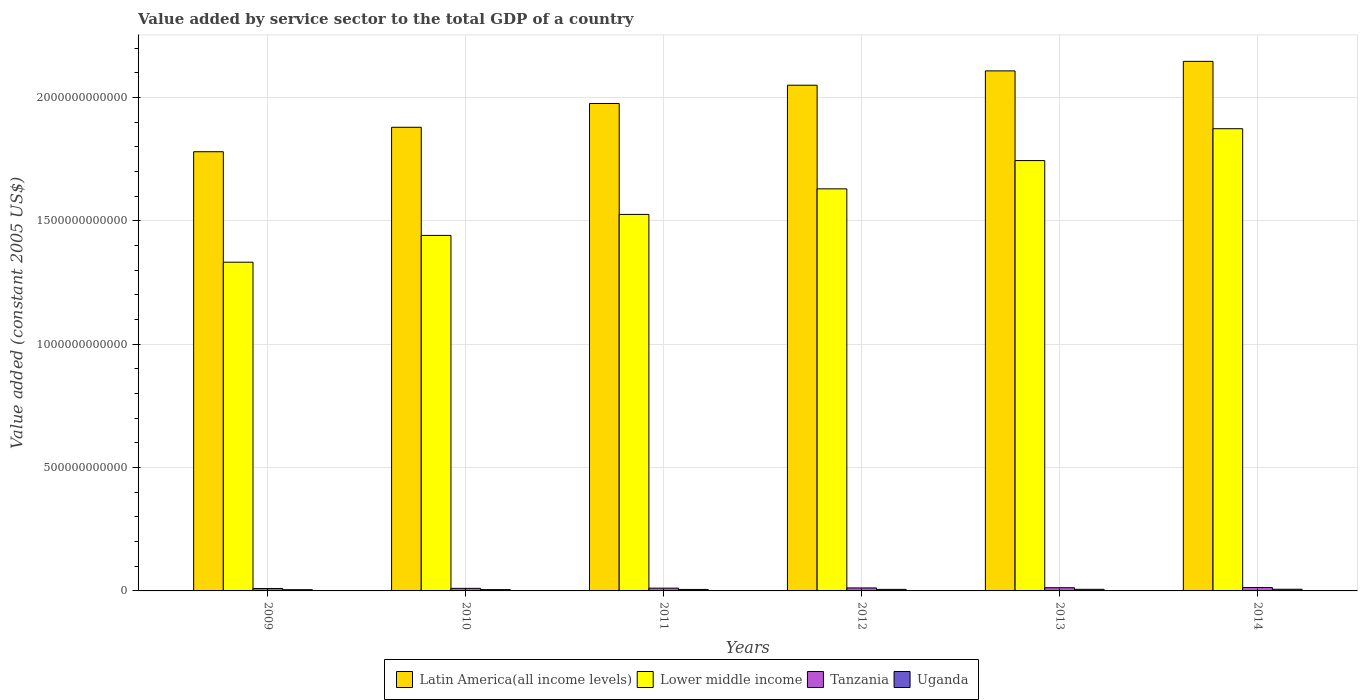How many groups of bars are there?
Keep it short and to the point. 6. Are the number of bars per tick equal to the number of legend labels?
Your answer should be very brief. Yes. How many bars are there on the 1st tick from the right?
Your answer should be very brief. 4. What is the label of the 1st group of bars from the left?
Make the answer very short. 2009. In how many cases, is the number of bars for a given year not equal to the number of legend labels?
Offer a very short reply. 0. What is the value added by service sector in Uganda in 2013?
Your answer should be very brief. 6.50e+09. Across all years, what is the maximum value added by service sector in Lower middle income?
Your answer should be compact. 1.87e+12. Across all years, what is the minimum value added by service sector in Latin America(all income levels)?
Ensure brevity in your answer.  1.78e+12. In which year was the value added by service sector in Lower middle income minimum?
Offer a terse response. 2009. What is the total value added by service sector in Latin America(all income levels) in the graph?
Give a very brief answer. 1.19e+13. What is the difference between the value added by service sector in Lower middle income in 2009 and that in 2013?
Your response must be concise. -4.12e+11. What is the difference between the value added by service sector in Uganda in 2010 and the value added by service sector in Lower middle income in 2012?
Provide a succinct answer. -1.62e+12. What is the average value added by service sector in Tanzania per year?
Offer a very short reply. 1.17e+1. In the year 2013, what is the difference between the value added by service sector in Lower middle income and value added by service sector in Tanzania?
Offer a very short reply. 1.73e+12. In how many years, is the value added by service sector in Lower middle income greater than 100000000000 US$?
Keep it short and to the point. 6. What is the ratio of the value added by service sector in Latin America(all income levels) in 2010 to that in 2014?
Give a very brief answer. 0.88. Is the difference between the value added by service sector in Lower middle income in 2010 and 2014 greater than the difference between the value added by service sector in Tanzania in 2010 and 2014?
Ensure brevity in your answer.  No. What is the difference between the highest and the second highest value added by service sector in Latin America(all income levels)?
Your answer should be very brief. 3.87e+1. What is the difference between the highest and the lowest value added by service sector in Uganda?
Make the answer very short. 1.78e+09. Is the sum of the value added by service sector in Latin America(all income levels) in 2012 and 2013 greater than the maximum value added by service sector in Tanzania across all years?
Ensure brevity in your answer.  Yes. What does the 4th bar from the left in 2014 represents?
Give a very brief answer. Uganda. What does the 4th bar from the right in 2014 represents?
Offer a very short reply. Latin America(all income levels). Is it the case that in every year, the sum of the value added by service sector in Tanzania and value added by service sector in Latin America(all income levels) is greater than the value added by service sector in Lower middle income?
Offer a terse response. Yes. Are all the bars in the graph horizontal?
Your response must be concise. No. How many years are there in the graph?
Provide a short and direct response. 6. What is the difference between two consecutive major ticks on the Y-axis?
Make the answer very short. 5.00e+11. Are the values on the major ticks of Y-axis written in scientific E-notation?
Provide a succinct answer. No. Does the graph contain any zero values?
Make the answer very short. No. How many legend labels are there?
Keep it short and to the point. 4. How are the legend labels stacked?
Offer a terse response. Horizontal. What is the title of the graph?
Your answer should be very brief. Value added by service sector to the total GDP of a country. Does "Thailand" appear as one of the legend labels in the graph?
Keep it short and to the point. No. What is the label or title of the X-axis?
Ensure brevity in your answer.  Years. What is the label or title of the Y-axis?
Your answer should be compact. Value added (constant 2005 US$). What is the Value added (constant 2005 US$) in Latin America(all income levels) in 2009?
Offer a terse response. 1.78e+12. What is the Value added (constant 2005 US$) in Lower middle income in 2009?
Ensure brevity in your answer.  1.33e+12. What is the Value added (constant 2005 US$) in Tanzania in 2009?
Your response must be concise. 9.69e+09. What is the Value added (constant 2005 US$) of Uganda in 2009?
Offer a terse response. 5.00e+09. What is the Value added (constant 2005 US$) in Latin America(all income levels) in 2010?
Your response must be concise. 1.88e+12. What is the Value added (constant 2005 US$) in Lower middle income in 2010?
Your response must be concise. 1.44e+12. What is the Value added (constant 2005 US$) of Tanzania in 2010?
Offer a very short reply. 1.04e+1. What is the Value added (constant 2005 US$) of Uganda in 2010?
Keep it short and to the point. 5.30e+09. What is the Value added (constant 2005 US$) in Latin America(all income levels) in 2011?
Provide a succinct answer. 1.98e+12. What is the Value added (constant 2005 US$) of Lower middle income in 2011?
Ensure brevity in your answer.  1.53e+12. What is the Value added (constant 2005 US$) in Tanzania in 2011?
Give a very brief answer. 1.13e+1. What is the Value added (constant 2005 US$) in Uganda in 2011?
Keep it short and to the point. 5.96e+09. What is the Value added (constant 2005 US$) in Latin America(all income levels) in 2012?
Offer a terse response. 2.05e+12. What is the Value added (constant 2005 US$) in Lower middle income in 2012?
Your answer should be very brief. 1.63e+12. What is the Value added (constant 2005 US$) in Tanzania in 2012?
Your response must be concise. 1.21e+1. What is the Value added (constant 2005 US$) in Uganda in 2012?
Provide a short and direct response. 6.25e+09. What is the Value added (constant 2005 US$) in Latin America(all income levels) in 2013?
Give a very brief answer. 2.11e+12. What is the Value added (constant 2005 US$) of Lower middle income in 2013?
Make the answer very short. 1.74e+12. What is the Value added (constant 2005 US$) of Tanzania in 2013?
Keep it short and to the point. 1.30e+1. What is the Value added (constant 2005 US$) in Uganda in 2013?
Your answer should be compact. 6.50e+09. What is the Value added (constant 2005 US$) in Latin America(all income levels) in 2014?
Offer a terse response. 2.15e+12. What is the Value added (constant 2005 US$) in Lower middle income in 2014?
Your answer should be compact. 1.87e+12. What is the Value added (constant 2005 US$) in Tanzania in 2014?
Provide a short and direct response. 1.39e+1. What is the Value added (constant 2005 US$) in Uganda in 2014?
Your response must be concise. 6.78e+09. Across all years, what is the maximum Value added (constant 2005 US$) in Latin America(all income levels)?
Your answer should be very brief. 2.15e+12. Across all years, what is the maximum Value added (constant 2005 US$) of Lower middle income?
Make the answer very short. 1.87e+12. Across all years, what is the maximum Value added (constant 2005 US$) in Tanzania?
Provide a short and direct response. 1.39e+1. Across all years, what is the maximum Value added (constant 2005 US$) in Uganda?
Your response must be concise. 6.78e+09. Across all years, what is the minimum Value added (constant 2005 US$) of Latin America(all income levels)?
Your response must be concise. 1.78e+12. Across all years, what is the minimum Value added (constant 2005 US$) in Lower middle income?
Ensure brevity in your answer.  1.33e+12. Across all years, what is the minimum Value added (constant 2005 US$) in Tanzania?
Offer a very short reply. 9.69e+09. Across all years, what is the minimum Value added (constant 2005 US$) in Uganda?
Provide a succinct answer. 5.00e+09. What is the total Value added (constant 2005 US$) of Latin America(all income levels) in the graph?
Offer a very short reply. 1.19e+13. What is the total Value added (constant 2005 US$) in Lower middle income in the graph?
Keep it short and to the point. 9.55e+12. What is the total Value added (constant 2005 US$) of Tanzania in the graph?
Your answer should be very brief. 7.04e+1. What is the total Value added (constant 2005 US$) of Uganda in the graph?
Ensure brevity in your answer.  3.58e+1. What is the difference between the Value added (constant 2005 US$) in Latin America(all income levels) in 2009 and that in 2010?
Offer a terse response. -9.91e+1. What is the difference between the Value added (constant 2005 US$) of Lower middle income in 2009 and that in 2010?
Your response must be concise. -1.09e+11. What is the difference between the Value added (constant 2005 US$) of Tanzania in 2009 and that in 2010?
Give a very brief answer. -7.53e+08. What is the difference between the Value added (constant 2005 US$) in Uganda in 2009 and that in 2010?
Ensure brevity in your answer.  -2.97e+08. What is the difference between the Value added (constant 2005 US$) in Latin America(all income levels) in 2009 and that in 2011?
Your answer should be compact. -1.96e+11. What is the difference between the Value added (constant 2005 US$) of Lower middle income in 2009 and that in 2011?
Your answer should be compact. -1.94e+11. What is the difference between the Value added (constant 2005 US$) of Tanzania in 2009 and that in 2011?
Keep it short and to the point. -1.58e+09. What is the difference between the Value added (constant 2005 US$) in Uganda in 2009 and that in 2011?
Offer a terse response. -9.52e+08. What is the difference between the Value added (constant 2005 US$) in Latin America(all income levels) in 2009 and that in 2012?
Your answer should be compact. -2.70e+11. What is the difference between the Value added (constant 2005 US$) of Lower middle income in 2009 and that in 2012?
Give a very brief answer. -2.97e+11. What is the difference between the Value added (constant 2005 US$) of Tanzania in 2009 and that in 2012?
Give a very brief answer. -2.42e+09. What is the difference between the Value added (constant 2005 US$) in Uganda in 2009 and that in 2012?
Make the answer very short. -1.25e+09. What is the difference between the Value added (constant 2005 US$) in Latin America(all income levels) in 2009 and that in 2013?
Make the answer very short. -3.28e+11. What is the difference between the Value added (constant 2005 US$) in Lower middle income in 2009 and that in 2013?
Give a very brief answer. -4.12e+11. What is the difference between the Value added (constant 2005 US$) in Tanzania in 2009 and that in 2013?
Make the answer very short. -3.31e+09. What is the difference between the Value added (constant 2005 US$) of Uganda in 2009 and that in 2013?
Give a very brief answer. -1.50e+09. What is the difference between the Value added (constant 2005 US$) of Latin America(all income levels) in 2009 and that in 2014?
Give a very brief answer. -3.66e+11. What is the difference between the Value added (constant 2005 US$) of Lower middle income in 2009 and that in 2014?
Offer a terse response. -5.41e+11. What is the difference between the Value added (constant 2005 US$) in Tanzania in 2009 and that in 2014?
Provide a short and direct response. -4.24e+09. What is the difference between the Value added (constant 2005 US$) of Uganda in 2009 and that in 2014?
Provide a short and direct response. -1.78e+09. What is the difference between the Value added (constant 2005 US$) of Latin America(all income levels) in 2010 and that in 2011?
Your response must be concise. -9.64e+1. What is the difference between the Value added (constant 2005 US$) of Lower middle income in 2010 and that in 2011?
Offer a very short reply. -8.51e+1. What is the difference between the Value added (constant 2005 US$) in Tanzania in 2010 and that in 2011?
Give a very brief answer. -8.30e+08. What is the difference between the Value added (constant 2005 US$) of Uganda in 2010 and that in 2011?
Your answer should be compact. -6.55e+08. What is the difference between the Value added (constant 2005 US$) in Latin America(all income levels) in 2010 and that in 2012?
Keep it short and to the point. -1.70e+11. What is the difference between the Value added (constant 2005 US$) of Lower middle income in 2010 and that in 2012?
Provide a short and direct response. -1.89e+11. What is the difference between the Value added (constant 2005 US$) in Tanzania in 2010 and that in 2012?
Provide a succinct answer. -1.67e+09. What is the difference between the Value added (constant 2005 US$) of Uganda in 2010 and that in 2012?
Offer a terse response. -9.49e+08. What is the difference between the Value added (constant 2005 US$) of Latin America(all income levels) in 2010 and that in 2013?
Keep it short and to the point. -2.29e+11. What is the difference between the Value added (constant 2005 US$) in Lower middle income in 2010 and that in 2013?
Your answer should be compact. -3.03e+11. What is the difference between the Value added (constant 2005 US$) in Tanzania in 2010 and that in 2013?
Give a very brief answer. -2.56e+09. What is the difference between the Value added (constant 2005 US$) of Uganda in 2010 and that in 2013?
Your answer should be compact. -1.20e+09. What is the difference between the Value added (constant 2005 US$) in Latin America(all income levels) in 2010 and that in 2014?
Your answer should be compact. -2.67e+11. What is the difference between the Value added (constant 2005 US$) of Lower middle income in 2010 and that in 2014?
Ensure brevity in your answer.  -4.33e+11. What is the difference between the Value added (constant 2005 US$) in Tanzania in 2010 and that in 2014?
Offer a terse response. -3.48e+09. What is the difference between the Value added (constant 2005 US$) of Uganda in 2010 and that in 2014?
Ensure brevity in your answer.  -1.48e+09. What is the difference between the Value added (constant 2005 US$) of Latin America(all income levels) in 2011 and that in 2012?
Your response must be concise. -7.41e+1. What is the difference between the Value added (constant 2005 US$) in Lower middle income in 2011 and that in 2012?
Ensure brevity in your answer.  -1.04e+11. What is the difference between the Value added (constant 2005 US$) in Tanzania in 2011 and that in 2012?
Give a very brief answer. -8.38e+08. What is the difference between the Value added (constant 2005 US$) of Uganda in 2011 and that in 2012?
Make the answer very short. -2.94e+08. What is the difference between the Value added (constant 2005 US$) in Latin America(all income levels) in 2011 and that in 2013?
Your answer should be very brief. -1.32e+11. What is the difference between the Value added (constant 2005 US$) of Lower middle income in 2011 and that in 2013?
Ensure brevity in your answer.  -2.18e+11. What is the difference between the Value added (constant 2005 US$) in Tanzania in 2011 and that in 2013?
Ensure brevity in your answer.  -1.73e+09. What is the difference between the Value added (constant 2005 US$) of Uganda in 2011 and that in 2013?
Give a very brief answer. -5.47e+08. What is the difference between the Value added (constant 2005 US$) of Latin America(all income levels) in 2011 and that in 2014?
Give a very brief answer. -1.71e+11. What is the difference between the Value added (constant 2005 US$) in Lower middle income in 2011 and that in 2014?
Your answer should be compact. -3.47e+11. What is the difference between the Value added (constant 2005 US$) of Tanzania in 2011 and that in 2014?
Your response must be concise. -2.65e+09. What is the difference between the Value added (constant 2005 US$) of Uganda in 2011 and that in 2014?
Ensure brevity in your answer.  -8.27e+08. What is the difference between the Value added (constant 2005 US$) of Latin America(all income levels) in 2012 and that in 2013?
Keep it short and to the point. -5.81e+1. What is the difference between the Value added (constant 2005 US$) in Lower middle income in 2012 and that in 2013?
Ensure brevity in your answer.  -1.15e+11. What is the difference between the Value added (constant 2005 US$) in Tanzania in 2012 and that in 2013?
Provide a succinct answer. -8.90e+08. What is the difference between the Value added (constant 2005 US$) in Uganda in 2012 and that in 2013?
Offer a terse response. -2.53e+08. What is the difference between the Value added (constant 2005 US$) in Latin America(all income levels) in 2012 and that in 2014?
Provide a succinct answer. -9.67e+1. What is the difference between the Value added (constant 2005 US$) in Lower middle income in 2012 and that in 2014?
Provide a short and direct response. -2.44e+11. What is the difference between the Value added (constant 2005 US$) in Tanzania in 2012 and that in 2014?
Keep it short and to the point. -1.82e+09. What is the difference between the Value added (constant 2005 US$) of Uganda in 2012 and that in 2014?
Provide a short and direct response. -5.33e+08. What is the difference between the Value added (constant 2005 US$) of Latin America(all income levels) in 2013 and that in 2014?
Your response must be concise. -3.87e+1. What is the difference between the Value added (constant 2005 US$) of Lower middle income in 2013 and that in 2014?
Ensure brevity in your answer.  -1.29e+11. What is the difference between the Value added (constant 2005 US$) in Tanzania in 2013 and that in 2014?
Give a very brief answer. -9.26e+08. What is the difference between the Value added (constant 2005 US$) of Uganda in 2013 and that in 2014?
Your answer should be compact. -2.80e+08. What is the difference between the Value added (constant 2005 US$) of Latin America(all income levels) in 2009 and the Value added (constant 2005 US$) of Lower middle income in 2010?
Keep it short and to the point. 3.39e+11. What is the difference between the Value added (constant 2005 US$) of Latin America(all income levels) in 2009 and the Value added (constant 2005 US$) of Tanzania in 2010?
Provide a succinct answer. 1.77e+12. What is the difference between the Value added (constant 2005 US$) in Latin America(all income levels) in 2009 and the Value added (constant 2005 US$) in Uganda in 2010?
Provide a short and direct response. 1.78e+12. What is the difference between the Value added (constant 2005 US$) of Lower middle income in 2009 and the Value added (constant 2005 US$) of Tanzania in 2010?
Provide a short and direct response. 1.32e+12. What is the difference between the Value added (constant 2005 US$) of Lower middle income in 2009 and the Value added (constant 2005 US$) of Uganda in 2010?
Give a very brief answer. 1.33e+12. What is the difference between the Value added (constant 2005 US$) in Tanzania in 2009 and the Value added (constant 2005 US$) in Uganda in 2010?
Make the answer very short. 4.39e+09. What is the difference between the Value added (constant 2005 US$) of Latin America(all income levels) in 2009 and the Value added (constant 2005 US$) of Lower middle income in 2011?
Your answer should be very brief. 2.54e+11. What is the difference between the Value added (constant 2005 US$) in Latin America(all income levels) in 2009 and the Value added (constant 2005 US$) in Tanzania in 2011?
Ensure brevity in your answer.  1.77e+12. What is the difference between the Value added (constant 2005 US$) in Latin America(all income levels) in 2009 and the Value added (constant 2005 US$) in Uganda in 2011?
Your answer should be very brief. 1.77e+12. What is the difference between the Value added (constant 2005 US$) in Lower middle income in 2009 and the Value added (constant 2005 US$) in Tanzania in 2011?
Offer a very short reply. 1.32e+12. What is the difference between the Value added (constant 2005 US$) in Lower middle income in 2009 and the Value added (constant 2005 US$) in Uganda in 2011?
Keep it short and to the point. 1.33e+12. What is the difference between the Value added (constant 2005 US$) of Tanzania in 2009 and the Value added (constant 2005 US$) of Uganda in 2011?
Keep it short and to the point. 3.74e+09. What is the difference between the Value added (constant 2005 US$) in Latin America(all income levels) in 2009 and the Value added (constant 2005 US$) in Lower middle income in 2012?
Your response must be concise. 1.51e+11. What is the difference between the Value added (constant 2005 US$) in Latin America(all income levels) in 2009 and the Value added (constant 2005 US$) in Tanzania in 2012?
Provide a short and direct response. 1.77e+12. What is the difference between the Value added (constant 2005 US$) of Latin America(all income levels) in 2009 and the Value added (constant 2005 US$) of Uganda in 2012?
Provide a short and direct response. 1.77e+12. What is the difference between the Value added (constant 2005 US$) of Lower middle income in 2009 and the Value added (constant 2005 US$) of Tanzania in 2012?
Offer a very short reply. 1.32e+12. What is the difference between the Value added (constant 2005 US$) of Lower middle income in 2009 and the Value added (constant 2005 US$) of Uganda in 2012?
Ensure brevity in your answer.  1.33e+12. What is the difference between the Value added (constant 2005 US$) of Tanzania in 2009 and the Value added (constant 2005 US$) of Uganda in 2012?
Your response must be concise. 3.44e+09. What is the difference between the Value added (constant 2005 US$) in Latin America(all income levels) in 2009 and the Value added (constant 2005 US$) in Lower middle income in 2013?
Give a very brief answer. 3.59e+1. What is the difference between the Value added (constant 2005 US$) in Latin America(all income levels) in 2009 and the Value added (constant 2005 US$) in Tanzania in 2013?
Offer a very short reply. 1.77e+12. What is the difference between the Value added (constant 2005 US$) of Latin America(all income levels) in 2009 and the Value added (constant 2005 US$) of Uganda in 2013?
Offer a very short reply. 1.77e+12. What is the difference between the Value added (constant 2005 US$) of Lower middle income in 2009 and the Value added (constant 2005 US$) of Tanzania in 2013?
Your response must be concise. 1.32e+12. What is the difference between the Value added (constant 2005 US$) of Lower middle income in 2009 and the Value added (constant 2005 US$) of Uganda in 2013?
Make the answer very short. 1.33e+12. What is the difference between the Value added (constant 2005 US$) in Tanzania in 2009 and the Value added (constant 2005 US$) in Uganda in 2013?
Keep it short and to the point. 3.19e+09. What is the difference between the Value added (constant 2005 US$) in Latin America(all income levels) in 2009 and the Value added (constant 2005 US$) in Lower middle income in 2014?
Your response must be concise. -9.33e+1. What is the difference between the Value added (constant 2005 US$) of Latin America(all income levels) in 2009 and the Value added (constant 2005 US$) of Tanzania in 2014?
Keep it short and to the point. 1.77e+12. What is the difference between the Value added (constant 2005 US$) of Latin America(all income levels) in 2009 and the Value added (constant 2005 US$) of Uganda in 2014?
Your answer should be compact. 1.77e+12. What is the difference between the Value added (constant 2005 US$) of Lower middle income in 2009 and the Value added (constant 2005 US$) of Tanzania in 2014?
Ensure brevity in your answer.  1.32e+12. What is the difference between the Value added (constant 2005 US$) of Lower middle income in 2009 and the Value added (constant 2005 US$) of Uganda in 2014?
Offer a very short reply. 1.33e+12. What is the difference between the Value added (constant 2005 US$) in Tanzania in 2009 and the Value added (constant 2005 US$) in Uganda in 2014?
Offer a terse response. 2.91e+09. What is the difference between the Value added (constant 2005 US$) in Latin America(all income levels) in 2010 and the Value added (constant 2005 US$) in Lower middle income in 2011?
Your answer should be very brief. 3.53e+11. What is the difference between the Value added (constant 2005 US$) in Latin America(all income levels) in 2010 and the Value added (constant 2005 US$) in Tanzania in 2011?
Provide a short and direct response. 1.87e+12. What is the difference between the Value added (constant 2005 US$) of Latin America(all income levels) in 2010 and the Value added (constant 2005 US$) of Uganda in 2011?
Provide a short and direct response. 1.87e+12. What is the difference between the Value added (constant 2005 US$) of Lower middle income in 2010 and the Value added (constant 2005 US$) of Tanzania in 2011?
Make the answer very short. 1.43e+12. What is the difference between the Value added (constant 2005 US$) of Lower middle income in 2010 and the Value added (constant 2005 US$) of Uganda in 2011?
Provide a short and direct response. 1.44e+12. What is the difference between the Value added (constant 2005 US$) of Tanzania in 2010 and the Value added (constant 2005 US$) of Uganda in 2011?
Ensure brevity in your answer.  4.49e+09. What is the difference between the Value added (constant 2005 US$) of Latin America(all income levels) in 2010 and the Value added (constant 2005 US$) of Lower middle income in 2012?
Make the answer very short. 2.50e+11. What is the difference between the Value added (constant 2005 US$) of Latin America(all income levels) in 2010 and the Value added (constant 2005 US$) of Tanzania in 2012?
Your response must be concise. 1.87e+12. What is the difference between the Value added (constant 2005 US$) in Latin America(all income levels) in 2010 and the Value added (constant 2005 US$) in Uganda in 2012?
Provide a succinct answer. 1.87e+12. What is the difference between the Value added (constant 2005 US$) of Lower middle income in 2010 and the Value added (constant 2005 US$) of Tanzania in 2012?
Your answer should be compact. 1.43e+12. What is the difference between the Value added (constant 2005 US$) in Lower middle income in 2010 and the Value added (constant 2005 US$) in Uganda in 2012?
Offer a terse response. 1.44e+12. What is the difference between the Value added (constant 2005 US$) of Tanzania in 2010 and the Value added (constant 2005 US$) of Uganda in 2012?
Provide a succinct answer. 4.19e+09. What is the difference between the Value added (constant 2005 US$) in Latin America(all income levels) in 2010 and the Value added (constant 2005 US$) in Lower middle income in 2013?
Provide a succinct answer. 1.35e+11. What is the difference between the Value added (constant 2005 US$) of Latin America(all income levels) in 2010 and the Value added (constant 2005 US$) of Tanzania in 2013?
Provide a succinct answer. 1.87e+12. What is the difference between the Value added (constant 2005 US$) of Latin America(all income levels) in 2010 and the Value added (constant 2005 US$) of Uganda in 2013?
Provide a short and direct response. 1.87e+12. What is the difference between the Value added (constant 2005 US$) in Lower middle income in 2010 and the Value added (constant 2005 US$) in Tanzania in 2013?
Your response must be concise. 1.43e+12. What is the difference between the Value added (constant 2005 US$) in Lower middle income in 2010 and the Value added (constant 2005 US$) in Uganda in 2013?
Keep it short and to the point. 1.43e+12. What is the difference between the Value added (constant 2005 US$) of Tanzania in 2010 and the Value added (constant 2005 US$) of Uganda in 2013?
Offer a very short reply. 3.94e+09. What is the difference between the Value added (constant 2005 US$) in Latin America(all income levels) in 2010 and the Value added (constant 2005 US$) in Lower middle income in 2014?
Provide a short and direct response. 5.84e+09. What is the difference between the Value added (constant 2005 US$) of Latin America(all income levels) in 2010 and the Value added (constant 2005 US$) of Tanzania in 2014?
Provide a succinct answer. 1.87e+12. What is the difference between the Value added (constant 2005 US$) in Latin America(all income levels) in 2010 and the Value added (constant 2005 US$) in Uganda in 2014?
Provide a succinct answer. 1.87e+12. What is the difference between the Value added (constant 2005 US$) in Lower middle income in 2010 and the Value added (constant 2005 US$) in Tanzania in 2014?
Provide a succinct answer. 1.43e+12. What is the difference between the Value added (constant 2005 US$) of Lower middle income in 2010 and the Value added (constant 2005 US$) of Uganda in 2014?
Your answer should be compact. 1.43e+12. What is the difference between the Value added (constant 2005 US$) of Tanzania in 2010 and the Value added (constant 2005 US$) of Uganda in 2014?
Offer a terse response. 3.66e+09. What is the difference between the Value added (constant 2005 US$) of Latin America(all income levels) in 2011 and the Value added (constant 2005 US$) of Lower middle income in 2012?
Provide a succinct answer. 3.46e+11. What is the difference between the Value added (constant 2005 US$) in Latin America(all income levels) in 2011 and the Value added (constant 2005 US$) in Tanzania in 2012?
Provide a short and direct response. 1.96e+12. What is the difference between the Value added (constant 2005 US$) in Latin America(all income levels) in 2011 and the Value added (constant 2005 US$) in Uganda in 2012?
Provide a short and direct response. 1.97e+12. What is the difference between the Value added (constant 2005 US$) of Lower middle income in 2011 and the Value added (constant 2005 US$) of Tanzania in 2012?
Give a very brief answer. 1.51e+12. What is the difference between the Value added (constant 2005 US$) in Lower middle income in 2011 and the Value added (constant 2005 US$) in Uganda in 2012?
Ensure brevity in your answer.  1.52e+12. What is the difference between the Value added (constant 2005 US$) in Tanzania in 2011 and the Value added (constant 2005 US$) in Uganda in 2012?
Offer a terse response. 5.02e+09. What is the difference between the Value added (constant 2005 US$) of Latin America(all income levels) in 2011 and the Value added (constant 2005 US$) of Lower middle income in 2013?
Your answer should be compact. 2.31e+11. What is the difference between the Value added (constant 2005 US$) of Latin America(all income levels) in 2011 and the Value added (constant 2005 US$) of Tanzania in 2013?
Provide a short and direct response. 1.96e+12. What is the difference between the Value added (constant 2005 US$) in Latin America(all income levels) in 2011 and the Value added (constant 2005 US$) in Uganda in 2013?
Your response must be concise. 1.97e+12. What is the difference between the Value added (constant 2005 US$) of Lower middle income in 2011 and the Value added (constant 2005 US$) of Tanzania in 2013?
Ensure brevity in your answer.  1.51e+12. What is the difference between the Value added (constant 2005 US$) of Lower middle income in 2011 and the Value added (constant 2005 US$) of Uganda in 2013?
Your answer should be compact. 1.52e+12. What is the difference between the Value added (constant 2005 US$) in Tanzania in 2011 and the Value added (constant 2005 US$) in Uganda in 2013?
Your response must be concise. 4.77e+09. What is the difference between the Value added (constant 2005 US$) in Latin America(all income levels) in 2011 and the Value added (constant 2005 US$) in Lower middle income in 2014?
Offer a very short reply. 1.02e+11. What is the difference between the Value added (constant 2005 US$) in Latin America(all income levels) in 2011 and the Value added (constant 2005 US$) in Tanzania in 2014?
Offer a terse response. 1.96e+12. What is the difference between the Value added (constant 2005 US$) in Latin America(all income levels) in 2011 and the Value added (constant 2005 US$) in Uganda in 2014?
Keep it short and to the point. 1.97e+12. What is the difference between the Value added (constant 2005 US$) of Lower middle income in 2011 and the Value added (constant 2005 US$) of Tanzania in 2014?
Your answer should be compact. 1.51e+12. What is the difference between the Value added (constant 2005 US$) in Lower middle income in 2011 and the Value added (constant 2005 US$) in Uganda in 2014?
Offer a terse response. 1.52e+12. What is the difference between the Value added (constant 2005 US$) of Tanzania in 2011 and the Value added (constant 2005 US$) of Uganda in 2014?
Your response must be concise. 4.49e+09. What is the difference between the Value added (constant 2005 US$) of Latin America(all income levels) in 2012 and the Value added (constant 2005 US$) of Lower middle income in 2013?
Ensure brevity in your answer.  3.06e+11. What is the difference between the Value added (constant 2005 US$) in Latin America(all income levels) in 2012 and the Value added (constant 2005 US$) in Tanzania in 2013?
Your response must be concise. 2.04e+12. What is the difference between the Value added (constant 2005 US$) in Latin America(all income levels) in 2012 and the Value added (constant 2005 US$) in Uganda in 2013?
Provide a short and direct response. 2.04e+12. What is the difference between the Value added (constant 2005 US$) of Lower middle income in 2012 and the Value added (constant 2005 US$) of Tanzania in 2013?
Your answer should be compact. 1.62e+12. What is the difference between the Value added (constant 2005 US$) of Lower middle income in 2012 and the Value added (constant 2005 US$) of Uganda in 2013?
Give a very brief answer. 1.62e+12. What is the difference between the Value added (constant 2005 US$) in Tanzania in 2012 and the Value added (constant 2005 US$) in Uganda in 2013?
Your answer should be very brief. 5.61e+09. What is the difference between the Value added (constant 2005 US$) of Latin America(all income levels) in 2012 and the Value added (constant 2005 US$) of Lower middle income in 2014?
Ensure brevity in your answer.  1.76e+11. What is the difference between the Value added (constant 2005 US$) in Latin America(all income levels) in 2012 and the Value added (constant 2005 US$) in Tanzania in 2014?
Offer a terse response. 2.04e+12. What is the difference between the Value added (constant 2005 US$) in Latin America(all income levels) in 2012 and the Value added (constant 2005 US$) in Uganda in 2014?
Keep it short and to the point. 2.04e+12. What is the difference between the Value added (constant 2005 US$) in Lower middle income in 2012 and the Value added (constant 2005 US$) in Tanzania in 2014?
Give a very brief answer. 1.62e+12. What is the difference between the Value added (constant 2005 US$) in Lower middle income in 2012 and the Value added (constant 2005 US$) in Uganda in 2014?
Keep it short and to the point. 1.62e+12. What is the difference between the Value added (constant 2005 US$) of Tanzania in 2012 and the Value added (constant 2005 US$) of Uganda in 2014?
Keep it short and to the point. 5.33e+09. What is the difference between the Value added (constant 2005 US$) of Latin America(all income levels) in 2013 and the Value added (constant 2005 US$) of Lower middle income in 2014?
Offer a terse response. 2.34e+11. What is the difference between the Value added (constant 2005 US$) of Latin America(all income levels) in 2013 and the Value added (constant 2005 US$) of Tanzania in 2014?
Offer a very short reply. 2.09e+12. What is the difference between the Value added (constant 2005 US$) of Latin America(all income levels) in 2013 and the Value added (constant 2005 US$) of Uganda in 2014?
Give a very brief answer. 2.10e+12. What is the difference between the Value added (constant 2005 US$) in Lower middle income in 2013 and the Value added (constant 2005 US$) in Tanzania in 2014?
Offer a terse response. 1.73e+12. What is the difference between the Value added (constant 2005 US$) of Lower middle income in 2013 and the Value added (constant 2005 US$) of Uganda in 2014?
Ensure brevity in your answer.  1.74e+12. What is the difference between the Value added (constant 2005 US$) of Tanzania in 2013 and the Value added (constant 2005 US$) of Uganda in 2014?
Offer a very short reply. 6.22e+09. What is the average Value added (constant 2005 US$) of Latin America(all income levels) per year?
Make the answer very short. 1.99e+12. What is the average Value added (constant 2005 US$) of Lower middle income per year?
Your answer should be compact. 1.59e+12. What is the average Value added (constant 2005 US$) in Tanzania per year?
Give a very brief answer. 1.17e+1. What is the average Value added (constant 2005 US$) of Uganda per year?
Your response must be concise. 5.96e+09. In the year 2009, what is the difference between the Value added (constant 2005 US$) in Latin America(all income levels) and Value added (constant 2005 US$) in Lower middle income?
Offer a very short reply. 4.48e+11. In the year 2009, what is the difference between the Value added (constant 2005 US$) in Latin America(all income levels) and Value added (constant 2005 US$) in Tanzania?
Your answer should be very brief. 1.77e+12. In the year 2009, what is the difference between the Value added (constant 2005 US$) in Latin America(all income levels) and Value added (constant 2005 US$) in Uganda?
Your response must be concise. 1.78e+12. In the year 2009, what is the difference between the Value added (constant 2005 US$) in Lower middle income and Value added (constant 2005 US$) in Tanzania?
Ensure brevity in your answer.  1.32e+12. In the year 2009, what is the difference between the Value added (constant 2005 US$) in Lower middle income and Value added (constant 2005 US$) in Uganda?
Keep it short and to the point. 1.33e+12. In the year 2009, what is the difference between the Value added (constant 2005 US$) in Tanzania and Value added (constant 2005 US$) in Uganda?
Keep it short and to the point. 4.69e+09. In the year 2010, what is the difference between the Value added (constant 2005 US$) of Latin America(all income levels) and Value added (constant 2005 US$) of Lower middle income?
Keep it short and to the point. 4.38e+11. In the year 2010, what is the difference between the Value added (constant 2005 US$) in Latin America(all income levels) and Value added (constant 2005 US$) in Tanzania?
Provide a short and direct response. 1.87e+12. In the year 2010, what is the difference between the Value added (constant 2005 US$) in Latin America(all income levels) and Value added (constant 2005 US$) in Uganda?
Provide a short and direct response. 1.87e+12. In the year 2010, what is the difference between the Value added (constant 2005 US$) in Lower middle income and Value added (constant 2005 US$) in Tanzania?
Your answer should be very brief. 1.43e+12. In the year 2010, what is the difference between the Value added (constant 2005 US$) of Lower middle income and Value added (constant 2005 US$) of Uganda?
Offer a very short reply. 1.44e+12. In the year 2010, what is the difference between the Value added (constant 2005 US$) in Tanzania and Value added (constant 2005 US$) in Uganda?
Your response must be concise. 5.14e+09. In the year 2011, what is the difference between the Value added (constant 2005 US$) in Latin America(all income levels) and Value added (constant 2005 US$) in Lower middle income?
Offer a very short reply. 4.50e+11. In the year 2011, what is the difference between the Value added (constant 2005 US$) of Latin America(all income levels) and Value added (constant 2005 US$) of Tanzania?
Offer a very short reply. 1.96e+12. In the year 2011, what is the difference between the Value added (constant 2005 US$) of Latin America(all income levels) and Value added (constant 2005 US$) of Uganda?
Provide a short and direct response. 1.97e+12. In the year 2011, what is the difference between the Value added (constant 2005 US$) of Lower middle income and Value added (constant 2005 US$) of Tanzania?
Your response must be concise. 1.52e+12. In the year 2011, what is the difference between the Value added (constant 2005 US$) in Lower middle income and Value added (constant 2005 US$) in Uganda?
Provide a short and direct response. 1.52e+12. In the year 2011, what is the difference between the Value added (constant 2005 US$) in Tanzania and Value added (constant 2005 US$) in Uganda?
Your response must be concise. 5.32e+09. In the year 2012, what is the difference between the Value added (constant 2005 US$) in Latin America(all income levels) and Value added (constant 2005 US$) in Lower middle income?
Give a very brief answer. 4.20e+11. In the year 2012, what is the difference between the Value added (constant 2005 US$) in Latin America(all income levels) and Value added (constant 2005 US$) in Tanzania?
Make the answer very short. 2.04e+12. In the year 2012, what is the difference between the Value added (constant 2005 US$) of Latin America(all income levels) and Value added (constant 2005 US$) of Uganda?
Your answer should be very brief. 2.04e+12. In the year 2012, what is the difference between the Value added (constant 2005 US$) of Lower middle income and Value added (constant 2005 US$) of Tanzania?
Provide a succinct answer. 1.62e+12. In the year 2012, what is the difference between the Value added (constant 2005 US$) in Lower middle income and Value added (constant 2005 US$) in Uganda?
Your answer should be compact. 1.62e+12. In the year 2012, what is the difference between the Value added (constant 2005 US$) of Tanzania and Value added (constant 2005 US$) of Uganda?
Keep it short and to the point. 5.86e+09. In the year 2013, what is the difference between the Value added (constant 2005 US$) of Latin America(all income levels) and Value added (constant 2005 US$) of Lower middle income?
Your answer should be very brief. 3.64e+11. In the year 2013, what is the difference between the Value added (constant 2005 US$) of Latin America(all income levels) and Value added (constant 2005 US$) of Tanzania?
Your response must be concise. 2.10e+12. In the year 2013, what is the difference between the Value added (constant 2005 US$) in Latin America(all income levels) and Value added (constant 2005 US$) in Uganda?
Provide a short and direct response. 2.10e+12. In the year 2013, what is the difference between the Value added (constant 2005 US$) of Lower middle income and Value added (constant 2005 US$) of Tanzania?
Keep it short and to the point. 1.73e+12. In the year 2013, what is the difference between the Value added (constant 2005 US$) in Lower middle income and Value added (constant 2005 US$) in Uganda?
Your answer should be very brief. 1.74e+12. In the year 2013, what is the difference between the Value added (constant 2005 US$) of Tanzania and Value added (constant 2005 US$) of Uganda?
Provide a short and direct response. 6.50e+09. In the year 2014, what is the difference between the Value added (constant 2005 US$) of Latin America(all income levels) and Value added (constant 2005 US$) of Lower middle income?
Keep it short and to the point. 2.73e+11. In the year 2014, what is the difference between the Value added (constant 2005 US$) in Latin America(all income levels) and Value added (constant 2005 US$) in Tanzania?
Ensure brevity in your answer.  2.13e+12. In the year 2014, what is the difference between the Value added (constant 2005 US$) in Latin America(all income levels) and Value added (constant 2005 US$) in Uganda?
Keep it short and to the point. 2.14e+12. In the year 2014, what is the difference between the Value added (constant 2005 US$) of Lower middle income and Value added (constant 2005 US$) of Tanzania?
Keep it short and to the point. 1.86e+12. In the year 2014, what is the difference between the Value added (constant 2005 US$) in Lower middle income and Value added (constant 2005 US$) in Uganda?
Give a very brief answer. 1.87e+12. In the year 2014, what is the difference between the Value added (constant 2005 US$) in Tanzania and Value added (constant 2005 US$) in Uganda?
Your response must be concise. 7.15e+09. What is the ratio of the Value added (constant 2005 US$) in Latin America(all income levels) in 2009 to that in 2010?
Ensure brevity in your answer.  0.95. What is the ratio of the Value added (constant 2005 US$) in Lower middle income in 2009 to that in 2010?
Keep it short and to the point. 0.92. What is the ratio of the Value added (constant 2005 US$) of Tanzania in 2009 to that in 2010?
Provide a short and direct response. 0.93. What is the ratio of the Value added (constant 2005 US$) of Uganda in 2009 to that in 2010?
Offer a very short reply. 0.94. What is the ratio of the Value added (constant 2005 US$) in Latin America(all income levels) in 2009 to that in 2011?
Keep it short and to the point. 0.9. What is the ratio of the Value added (constant 2005 US$) of Lower middle income in 2009 to that in 2011?
Provide a short and direct response. 0.87. What is the ratio of the Value added (constant 2005 US$) of Tanzania in 2009 to that in 2011?
Offer a very short reply. 0.86. What is the ratio of the Value added (constant 2005 US$) of Uganda in 2009 to that in 2011?
Provide a succinct answer. 0.84. What is the ratio of the Value added (constant 2005 US$) of Latin America(all income levels) in 2009 to that in 2012?
Make the answer very short. 0.87. What is the ratio of the Value added (constant 2005 US$) in Lower middle income in 2009 to that in 2012?
Ensure brevity in your answer.  0.82. What is the ratio of the Value added (constant 2005 US$) of Tanzania in 2009 to that in 2012?
Keep it short and to the point. 0.8. What is the ratio of the Value added (constant 2005 US$) in Uganda in 2009 to that in 2012?
Offer a terse response. 0.8. What is the ratio of the Value added (constant 2005 US$) of Latin America(all income levels) in 2009 to that in 2013?
Offer a very short reply. 0.84. What is the ratio of the Value added (constant 2005 US$) in Lower middle income in 2009 to that in 2013?
Offer a terse response. 0.76. What is the ratio of the Value added (constant 2005 US$) of Tanzania in 2009 to that in 2013?
Your answer should be compact. 0.75. What is the ratio of the Value added (constant 2005 US$) in Uganda in 2009 to that in 2013?
Your answer should be compact. 0.77. What is the ratio of the Value added (constant 2005 US$) of Latin America(all income levels) in 2009 to that in 2014?
Make the answer very short. 0.83. What is the ratio of the Value added (constant 2005 US$) of Lower middle income in 2009 to that in 2014?
Give a very brief answer. 0.71. What is the ratio of the Value added (constant 2005 US$) of Tanzania in 2009 to that in 2014?
Your answer should be compact. 0.7. What is the ratio of the Value added (constant 2005 US$) in Uganda in 2009 to that in 2014?
Provide a short and direct response. 0.74. What is the ratio of the Value added (constant 2005 US$) of Latin America(all income levels) in 2010 to that in 2011?
Your answer should be very brief. 0.95. What is the ratio of the Value added (constant 2005 US$) in Lower middle income in 2010 to that in 2011?
Make the answer very short. 0.94. What is the ratio of the Value added (constant 2005 US$) in Tanzania in 2010 to that in 2011?
Ensure brevity in your answer.  0.93. What is the ratio of the Value added (constant 2005 US$) of Uganda in 2010 to that in 2011?
Your answer should be compact. 0.89. What is the ratio of the Value added (constant 2005 US$) in Latin America(all income levels) in 2010 to that in 2012?
Keep it short and to the point. 0.92. What is the ratio of the Value added (constant 2005 US$) in Lower middle income in 2010 to that in 2012?
Make the answer very short. 0.88. What is the ratio of the Value added (constant 2005 US$) in Tanzania in 2010 to that in 2012?
Your response must be concise. 0.86. What is the ratio of the Value added (constant 2005 US$) in Uganda in 2010 to that in 2012?
Offer a terse response. 0.85. What is the ratio of the Value added (constant 2005 US$) in Latin America(all income levels) in 2010 to that in 2013?
Offer a very short reply. 0.89. What is the ratio of the Value added (constant 2005 US$) in Lower middle income in 2010 to that in 2013?
Your response must be concise. 0.83. What is the ratio of the Value added (constant 2005 US$) in Tanzania in 2010 to that in 2013?
Your answer should be compact. 0.8. What is the ratio of the Value added (constant 2005 US$) in Uganda in 2010 to that in 2013?
Ensure brevity in your answer.  0.82. What is the ratio of the Value added (constant 2005 US$) of Latin America(all income levels) in 2010 to that in 2014?
Your answer should be very brief. 0.88. What is the ratio of the Value added (constant 2005 US$) of Lower middle income in 2010 to that in 2014?
Offer a terse response. 0.77. What is the ratio of the Value added (constant 2005 US$) in Tanzania in 2010 to that in 2014?
Make the answer very short. 0.75. What is the ratio of the Value added (constant 2005 US$) of Uganda in 2010 to that in 2014?
Your answer should be compact. 0.78. What is the ratio of the Value added (constant 2005 US$) of Latin America(all income levels) in 2011 to that in 2012?
Ensure brevity in your answer.  0.96. What is the ratio of the Value added (constant 2005 US$) of Lower middle income in 2011 to that in 2012?
Your answer should be very brief. 0.94. What is the ratio of the Value added (constant 2005 US$) of Tanzania in 2011 to that in 2012?
Offer a very short reply. 0.93. What is the ratio of the Value added (constant 2005 US$) of Uganda in 2011 to that in 2012?
Your answer should be compact. 0.95. What is the ratio of the Value added (constant 2005 US$) in Latin America(all income levels) in 2011 to that in 2013?
Offer a terse response. 0.94. What is the ratio of the Value added (constant 2005 US$) of Lower middle income in 2011 to that in 2013?
Ensure brevity in your answer.  0.87. What is the ratio of the Value added (constant 2005 US$) of Tanzania in 2011 to that in 2013?
Provide a succinct answer. 0.87. What is the ratio of the Value added (constant 2005 US$) of Uganda in 2011 to that in 2013?
Give a very brief answer. 0.92. What is the ratio of the Value added (constant 2005 US$) in Latin America(all income levels) in 2011 to that in 2014?
Keep it short and to the point. 0.92. What is the ratio of the Value added (constant 2005 US$) in Lower middle income in 2011 to that in 2014?
Give a very brief answer. 0.81. What is the ratio of the Value added (constant 2005 US$) of Tanzania in 2011 to that in 2014?
Provide a succinct answer. 0.81. What is the ratio of the Value added (constant 2005 US$) in Uganda in 2011 to that in 2014?
Your answer should be very brief. 0.88. What is the ratio of the Value added (constant 2005 US$) in Latin America(all income levels) in 2012 to that in 2013?
Ensure brevity in your answer.  0.97. What is the ratio of the Value added (constant 2005 US$) of Lower middle income in 2012 to that in 2013?
Offer a terse response. 0.93. What is the ratio of the Value added (constant 2005 US$) of Tanzania in 2012 to that in 2013?
Provide a short and direct response. 0.93. What is the ratio of the Value added (constant 2005 US$) of Uganda in 2012 to that in 2013?
Your response must be concise. 0.96. What is the ratio of the Value added (constant 2005 US$) of Latin America(all income levels) in 2012 to that in 2014?
Your answer should be very brief. 0.95. What is the ratio of the Value added (constant 2005 US$) of Lower middle income in 2012 to that in 2014?
Keep it short and to the point. 0.87. What is the ratio of the Value added (constant 2005 US$) of Tanzania in 2012 to that in 2014?
Give a very brief answer. 0.87. What is the ratio of the Value added (constant 2005 US$) of Uganda in 2012 to that in 2014?
Keep it short and to the point. 0.92. What is the ratio of the Value added (constant 2005 US$) in Latin America(all income levels) in 2013 to that in 2014?
Keep it short and to the point. 0.98. What is the ratio of the Value added (constant 2005 US$) of Lower middle income in 2013 to that in 2014?
Offer a very short reply. 0.93. What is the ratio of the Value added (constant 2005 US$) in Tanzania in 2013 to that in 2014?
Offer a terse response. 0.93. What is the ratio of the Value added (constant 2005 US$) in Uganda in 2013 to that in 2014?
Your answer should be very brief. 0.96. What is the difference between the highest and the second highest Value added (constant 2005 US$) in Latin America(all income levels)?
Provide a succinct answer. 3.87e+1. What is the difference between the highest and the second highest Value added (constant 2005 US$) of Lower middle income?
Ensure brevity in your answer.  1.29e+11. What is the difference between the highest and the second highest Value added (constant 2005 US$) in Tanzania?
Your response must be concise. 9.26e+08. What is the difference between the highest and the second highest Value added (constant 2005 US$) in Uganda?
Provide a succinct answer. 2.80e+08. What is the difference between the highest and the lowest Value added (constant 2005 US$) in Latin America(all income levels)?
Give a very brief answer. 3.66e+11. What is the difference between the highest and the lowest Value added (constant 2005 US$) in Lower middle income?
Provide a short and direct response. 5.41e+11. What is the difference between the highest and the lowest Value added (constant 2005 US$) of Tanzania?
Offer a very short reply. 4.24e+09. What is the difference between the highest and the lowest Value added (constant 2005 US$) in Uganda?
Offer a very short reply. 1.78e+09. 